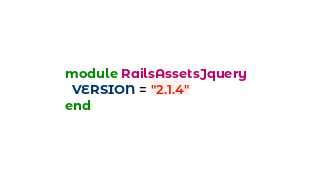<code> <loc_0><loc_0><loc_500><loc_500><_Ruby_>module RailsAssetsJquery
  VERSION = "2.1.4"
end
</code> 